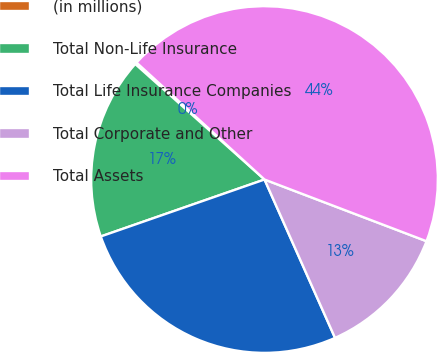Convert chart. <chart><loc_0><loc_0><loc_500><loc_500><pie_chart><fcel>(in millions)<fcel>Total Non-Life Insurance<fcel>Total Life Insurance Companies<fcel>Total Corporate and Other<fcel>Total Assets<nl><fcel>0.18%<fcel>16.93%<fcel>26.34%<fcel>12.54%<fcel>44.01%<nl></chart> 